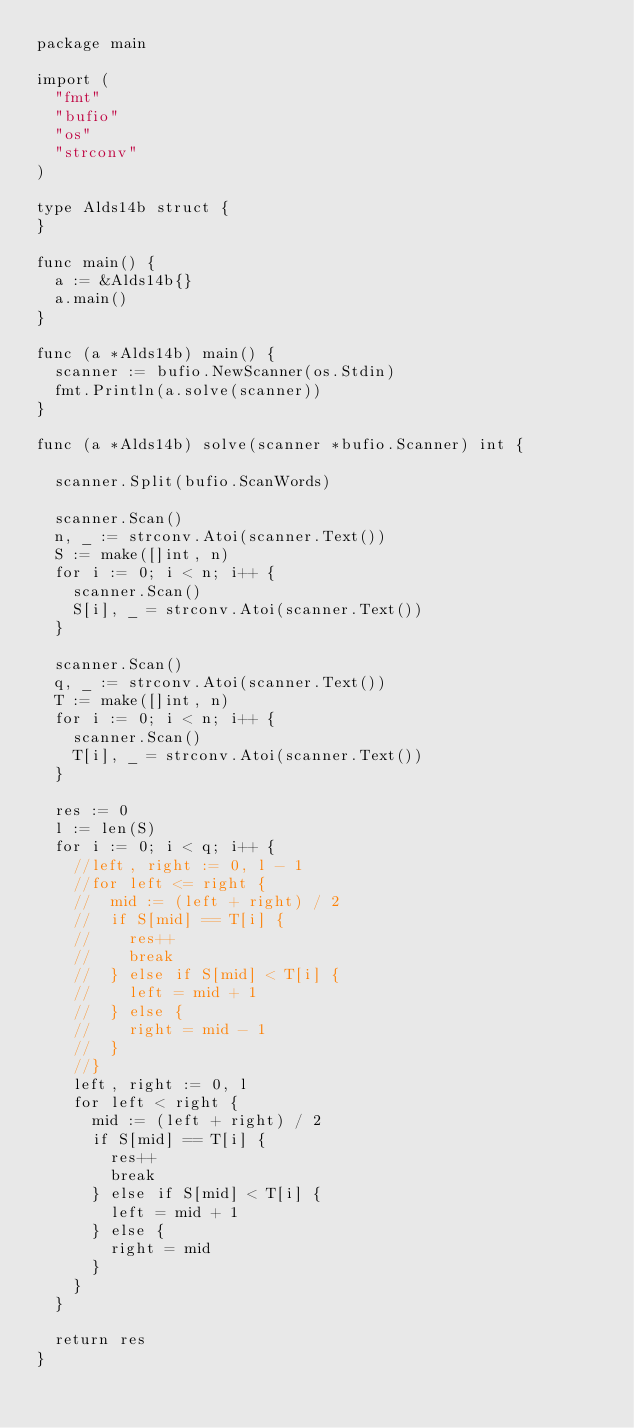<code> <loc_0><loc_0><loc_500><loc_500><_Go_>package main

import (
	"fmt"
	"bufio"
	"os"
	"strconv"
)

type Alds14b struct {
}

func main() {
	a := &Alds14b{}
	a.main()
}

func (a *Alds14b) main() {
	scanner := bufio.NewScanner(os.Stdin)
	fmt.Println(a.solve(scanner))
}

func (a *Alds14b) solve(scanner *bufio.Scanner) int {

	scanner.Split(bufio.ScanWords)

	scanner.Scan()
	n, _ := strconv.Atoi(scanner.Text())
	S := make([]int, n)
	for i := 0; i < n; i++ {
		scanner.Scan()
		S[i], _ = strconv.Atoi(scanner.Text())
	}

	scanner.Scan()
	q, _ := strconv.Atoi(scanner.Text())
	T := make([]int, n)
	for i := 0; i < n; i++ {
		scanner.Scan()
		T[i], _ = strconv.Atoi(scanner.Text())
	}

	res := 0
	l := len(S)
	for i := 0; i < q; i++ {
		//left, right := 0, l - 1
		//for left <= right {
		//	mid := (left + right) / 2
		//	if S[mid] == T[i] {
		//		res++
		//		break
		//	} else if S[mid] < T[i] {
		//		left = mid + 1
		//	} else {
		//		right = mid - 1
		//	}
		//}
		left, right := 0, l
		for left < right {
			mid := (left + right) / 2
			if S[mid] == T[i] {
				res++
				break
			} else if S[mid] < T[i] {
				left = mid + 1
			} else {
				right = mid
			}
		}
	}

	return res
}

</code> 